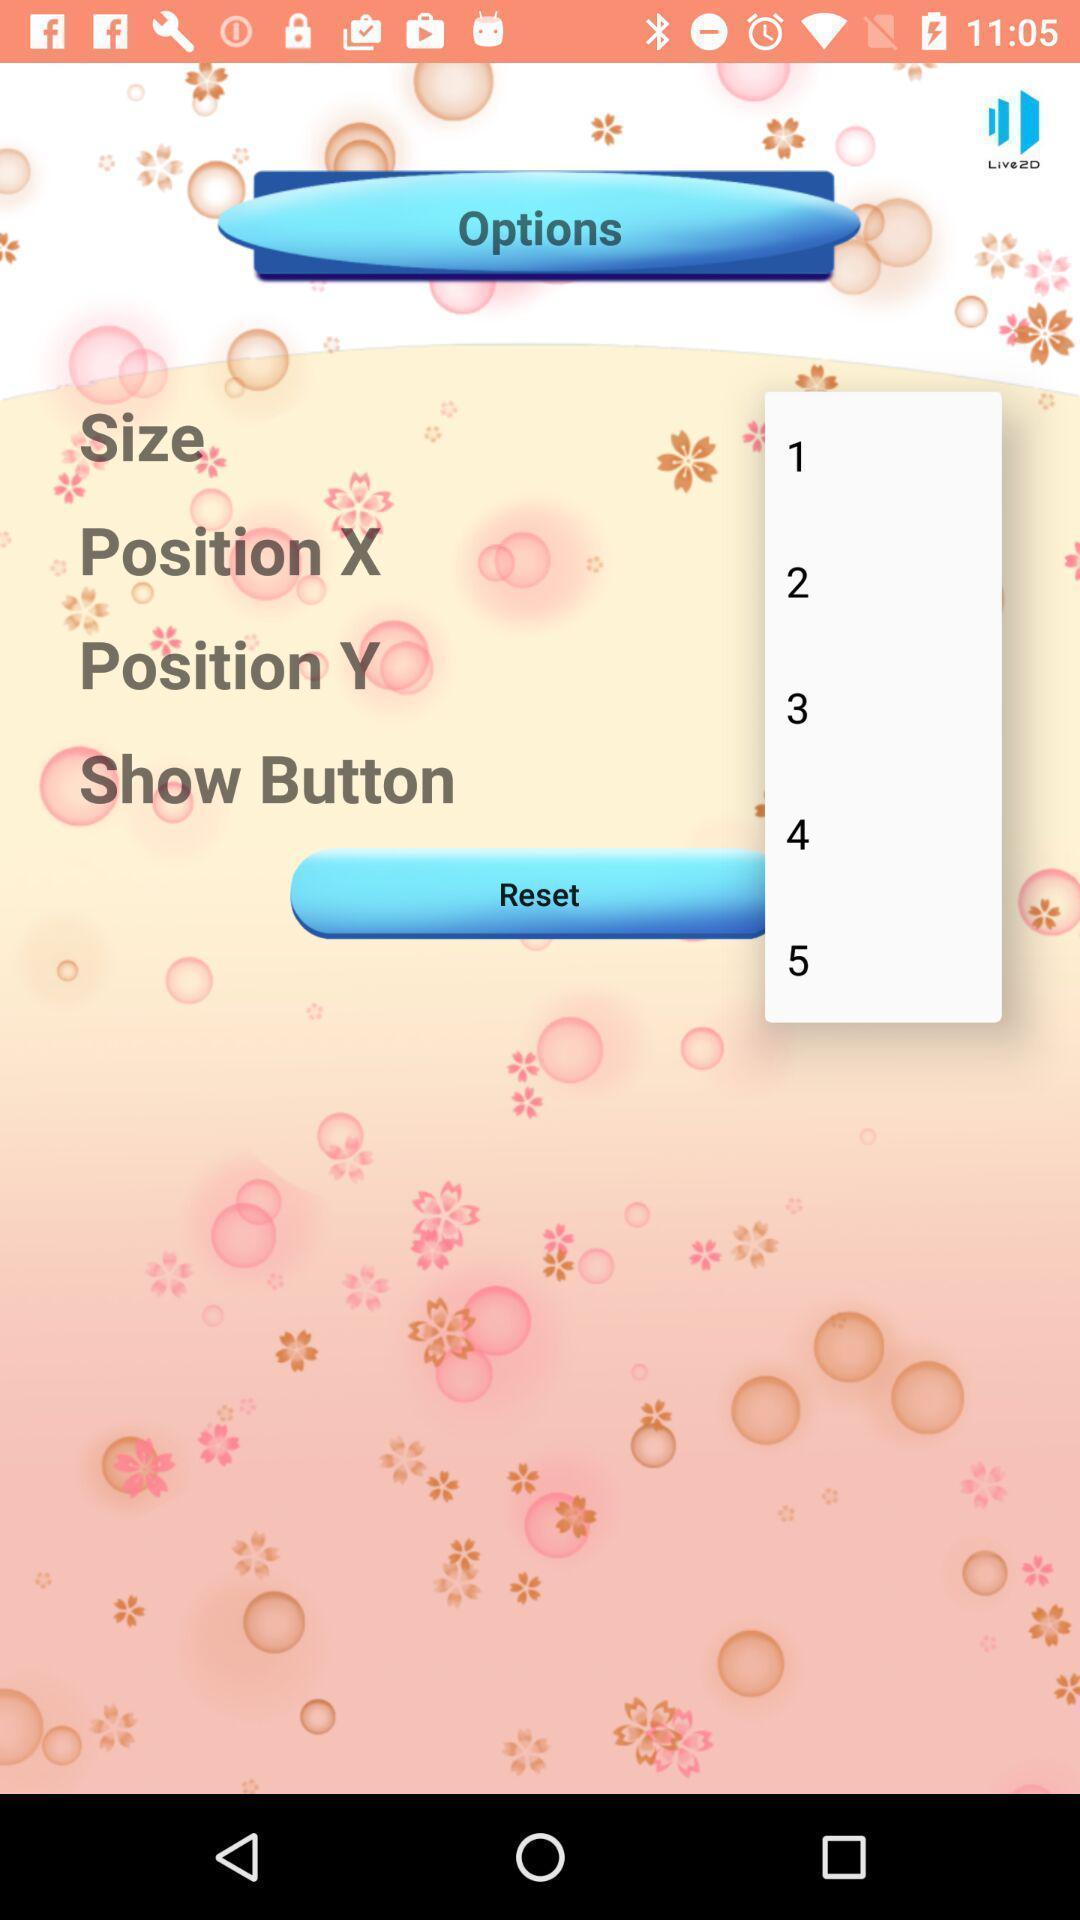Describe the content in this image. Screen showing multiple options. 